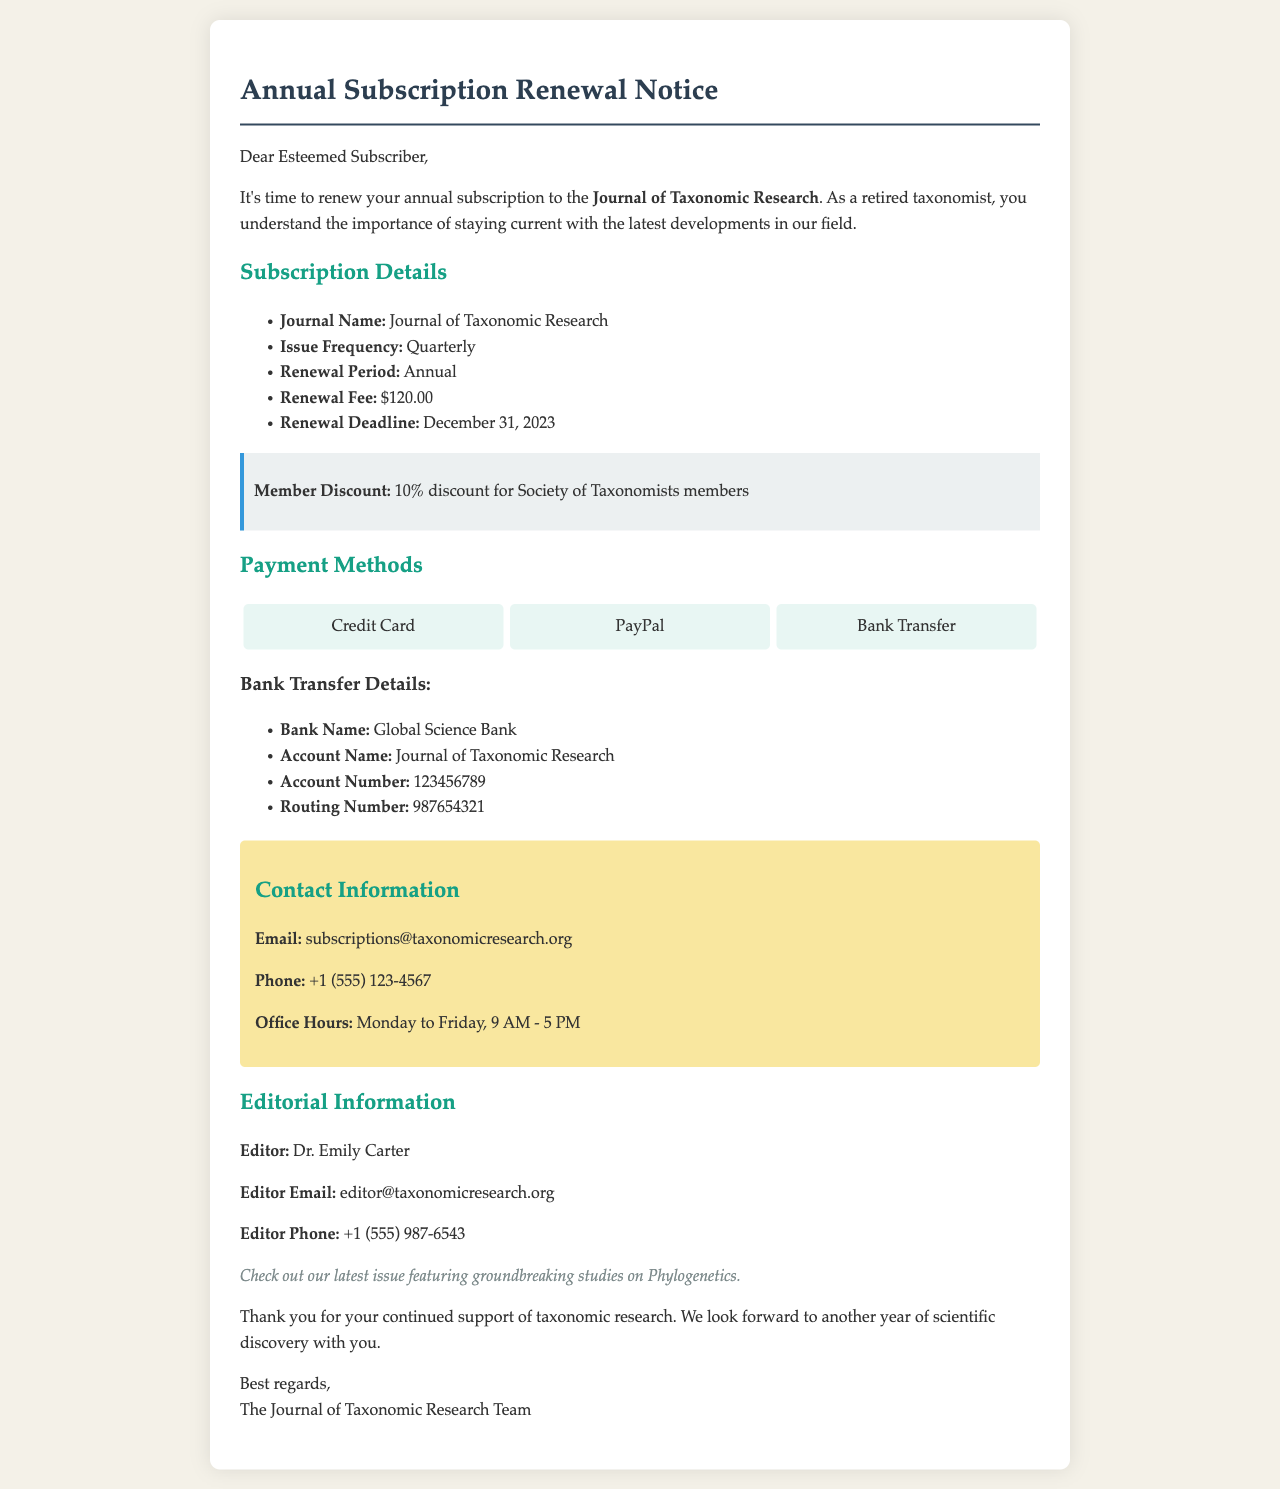What is the name of the journal? The name of the journal is stated in the letter, which is "Journal of Taxonomic Research."
Answer: Journal of Taxonomic Research What is the renewal fee for the subscription? The renewal fee for the subscription is specified in the document.
Answer: $120.00 What is the renewal deadline? The renewal deadline is provided as a specific date in the letter.
Answer: December 31, 2023 What discount is offered to Society of Taxonomists members? The document mentions a specific discount for members of the Society of Taxonomists.
Answer: 10% Who is the editor of the journal? The editor's name is mentioned in the editorial information section of the letter.
Answer: Dr. Emily Carter How often is the journal published? The document details the publication frequency in the subscription details section.
Answer: Quarterly What payment methods are available? The letter lists various methods for making payments towards the subscription.
Answer: Credit Card, PayPal, Bank Transfer What is the email address for subscription inquiries? The document specifies the email address for contacting about subscriptions.
Answer: subscriptions@taxonomicresearch.org What is the name of the bank for bank transfers? The bank name is provided in the payment instructions in the document.
Answer: Global Science Bank 